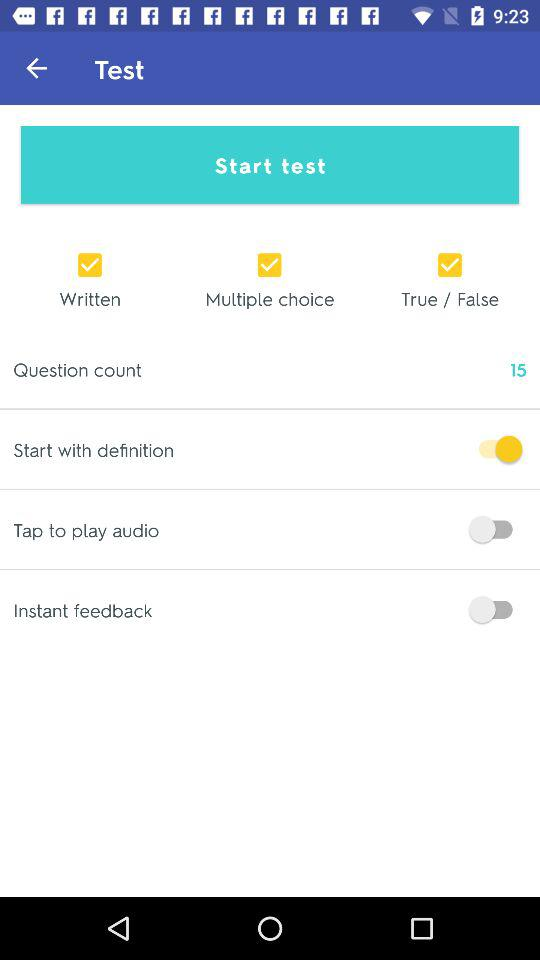How many "Question Counts" are there? The "Question Count" is 15. 